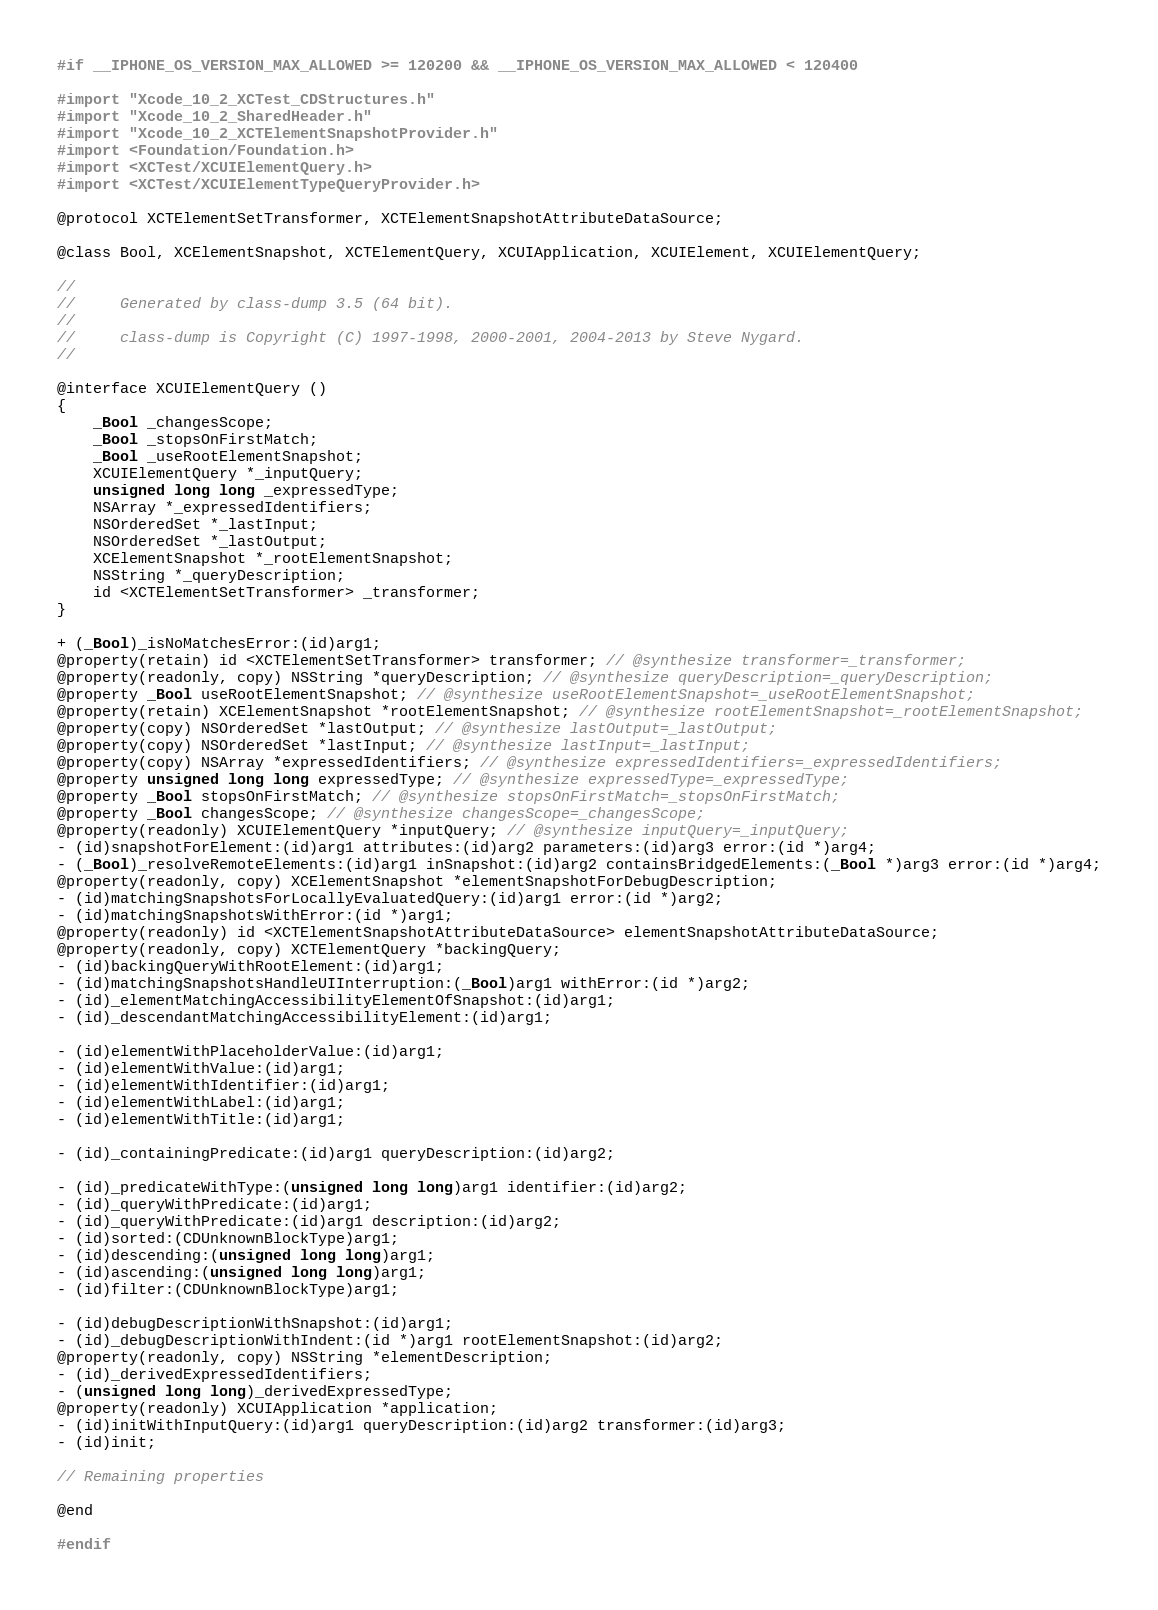Convert code to text. <code><loc_0><loc_0><loc_500><loc_500><_C_>#if __IPHONE_OS_VERSION_MAX_ALLOWED >= 120200 && __IPHONE_OS_VERSION_MAX_ALLOWED < 120400

#import "Xcode_10_2_XCTest_CDStructures.h"
#import "Xcode_10_2_SharedHeader.h"
#import "Xcode_10_2_XCTElementSnapshotProvider.h"
#import <Foundation/Foundation.h>
#import <XCTest/XCUIElementQuery.h>
#import <XCTest/XCUIElementTypeQueryProvider.h>

@protocol XCTElementSetTransformer, XCTElementSnapshotAttributeDataSource;

@class Bool, XCElementSnapshot, XCTElementQuery, XCUIApplication, XCUIElement, XCUIElementQuery;

//
//     Generated by class-dump 3.5 (64 bit).
//
//     class-dump is Copyright (C) 1997-1998, 2000-2001, 2004-2013 by Steve Nygard.
//

@interface XCUIElementQuery ()
{
    _Bool _changesScope;
    _Bool _stopsOnFirstMatch;
    _Bool _useRootElementSnapshot;
    XCUIElementQuery *_inputQuery;
    unsigned long long _expressedType;
    NSArray *_expressedIdentifiers;
    NSOrderedSet *_lastInput;
    NSOrderedSet *_lastOutput;
    XCElementSnapshot *_rootElementSnapshot;
    NSString *_queryDescription;
    id <XCTElementSetTransformer> _transformer;
}

+ (_Bool)_isNoMatchesError:(id)arg1;
@property(retain) id <XCTElementSetTransformer> transformer; // @synthesize transformer=_transformer;
@property(readonly, copy) NSString *queryDescription; // @synthesize queryDescription=_queryDescription;
@property _Bool useRootElementSnapshot; // @synthesize useRootElementSnapshot=_useRootElementSnapshot;
@property(retain) XCElementSnapshot *rootElementSnapshot; // @synthesize rootElementSnapshot=_rootElementSnapshot;
@property(copy) NSOrderedSet *lastOutput; // @synthesize lastOutput=_lastOutput;
@property(copy) NSOrderedSet *lastInput; // @synthesize lastInput=_lastInput;
@property(copy) NSArray *expressedIdentifiers; // @synthesize expressedIdentifiers=_expressedIdentifiers;
@property unsigned long long expressedType; // @synthesize expressedType=_expressedType;
@property _Bool stopsOnFirstMatch; // @synthesize stopsOnFirstMatch=_stopsOnFirstMatch;
@property _Bool changesScope; // @synthesize changesScope=_changesScope;
@property(readonly) XCUIElementQuery *inputQuery; // @synthesize inputQuery=_inputQuery;
- (id)snapshotForElement:(id)arg1 attributes:(id)arg2 parameters:(id)arg3 error:(id *)arg4;
- (_Bool)_resolveRemoteElements:(id)arg1 inSnapshot:(id)arg2 containsBridgedElements:(_Bool *)arg3 error:(id *)arg4;
@property(readonly, copy) XCElementSnapshot *elementSnapshotForDebugDescription;
- (id)matchingSnapshotsForLocallyEvaluatedQuery:(id)arg1 error:(id *)arg2;
- (id)matchingSnapshotsWithError:(id *)arg1;
@property(readonly) id <XCTElementSnapshotAttributeDataSource> elementSnapshotAttributeDataSource;
@property(readonly, copy) XCTElementQuery *backingQuery;
- (id)backingQueryWithRootElement:(id)arg1;
- (id)matchingSnapshotsHandleUIInterruption:(_Bool)arg1 withError:(id *)arg2;
- (id)_elementMatchingAccessibilityElementOfSnapshot:(id)arg1;
- (id)_descendantMatchingAccessibilityElement:(id)arg1;

- (id)elementWithPlaceholderValue:(id)arg1;
- (id)elementWithValue:(id)arg1;
- (id)elementWithIdentifier:(id)arg1;
- (id)elementWithLabel:(id)arg1;
- (id)elementWithTitle:(id)arg1;

- (id)_containingPredicate:(id)arg1 queryDescription:(id)arg2;

- (id)_predicateWithType:(unsigned long long)arg1 identifier:(id)arg2;
- (id)_queryWithPredicate:(id)arg1;
- (id)_queryWithPredicate:(id)arg1 description:(id)arg2;
- (id)sorted:(CDUnknownBlockType)arg1;
- (id)descending:(unsigned long long)arg1;
- (id)ascending:(unsigned long long)arg1;
- (id)filter:(CDUnknownBlockType)arg1;

- (id)debugDescriptionWithSnapshot:(id)arg1;
- (id)_debugDescriptionWithIndent:(id *)arg1 rootElementSnapshot:(id)arg2;
@property(readonly, copy) NSString *elementDescription;
- (id)_derivedExpressedIdentifiers;
- (unsigned long long)_derivedExpressedType;
@property(readonly) XCUIApplication *application;
- (id)initWithInputQuery:(id)arg1 queryDescription:(id)arg2 transformer:(id)arg3;
- (id)init;

// Remaining properties

@end

#endif
</code> 